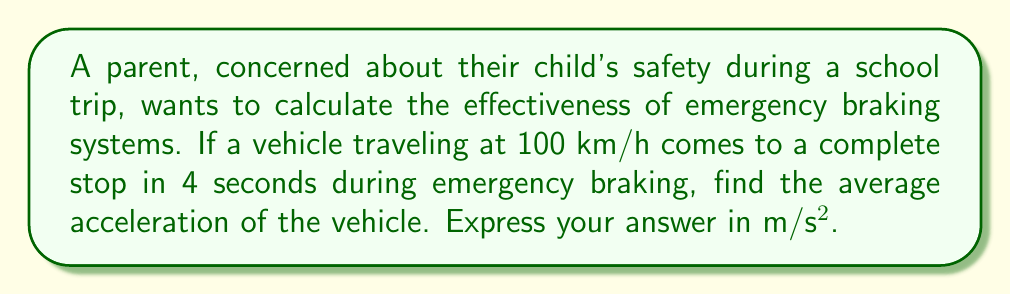Give your solution to this math problem. Let's approach this step-by-step:

1) First, we need to convert the initial velocity from km/h to m/s:
   $100 \text{ km/h} = 100 \times \frac{1000 \text{ m}}{3600 \text{ s}} = \frac{250}{9} \text{ m/s} \approx 27.78 \text{ m/s}$

2) We know that the final velocity is 0 m/s (the vehicle comes to a complete stop).

3) The time taken is 4 seconds.

4) We can use the equation for average acceleration:
   $a = \frac{v_f - v_i}{t}$

   Where:
   $a$ is the acceleration
   $v_f$ is the final velocity
   $v_i$ is the initial velocity
   $t$ is the time taken

5) Substituting our values:
   $a = \frac{0 - \frac{250}{9}}{4} = -\frac{250}{36} \text{ m/s²}$

6) Simplifying:
   $a = -6.94 \text{ m/s²}$

7) The negative sign indicates deceleration (slowing down).
Answer: $-6.94 \text{ m/s²}$ 